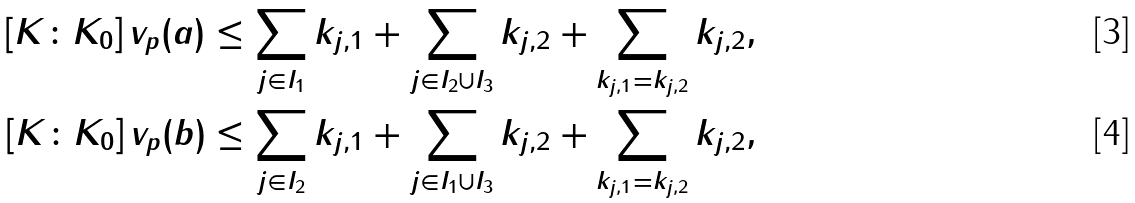Convert formula to latex. <formula><loc_0><loc_0><loc_500><loc_500>[ K \colon K _ { 0 } ] \, v _ { p } ( a ) & \leq \sum _ { j \in I _ { 1 } } k _ { j , 1 } + \sum _ { j \in I _ { 2 } \cup I _ { 3 } } k _ { j , 2 } + \sum _ { k _ { j , 1 } = k _ { j , 2 } } k _ { j , 2 } , \\ [ K \colon K _ { 0 } ] \, v _ { p } ( b ) & \leq \sum _ { j \in I _ { 2 } } k _ { j , 1 } + \sum _ { j \in I _ { 1 } \cup I _ { 3 } } k _ { j , 2 } + \sum _ { k _ { j , 1 } = k _ { j , 2 } } k _ { j , 2 } ,</formula> 